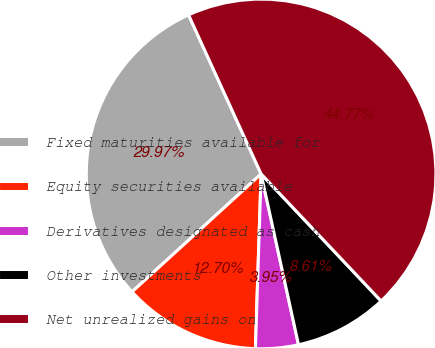Convert chart to OTSL. <chart><loc_0><loc_0><loc_500><loc_500><pie_chart><fcel>Fixed maturities available for<fcel>Equity securities available<fcel>Derivatives designated as cash<fcel>Other investments<fcel>Net unrealized gains on<nl><fcel>29.97%<fcel>12.7%<fcel>3.95%<fcel>8.61%<fcel>44.77%<nl></chart> 